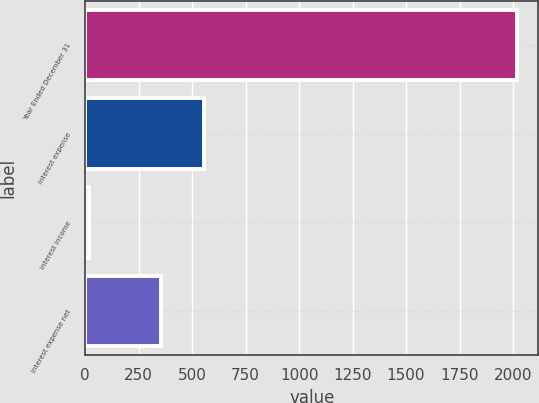Convert chart. <chart><loc_0><loc_0><loc_500><loc_500><bar_chart><fcel>Year Ended December 31<fcel>Interest expense<fcel>Interest income<fcel>Interest expense net<nl><fcel>2018<fcel>556<fcel>18<fcel>356<nl></chart> 